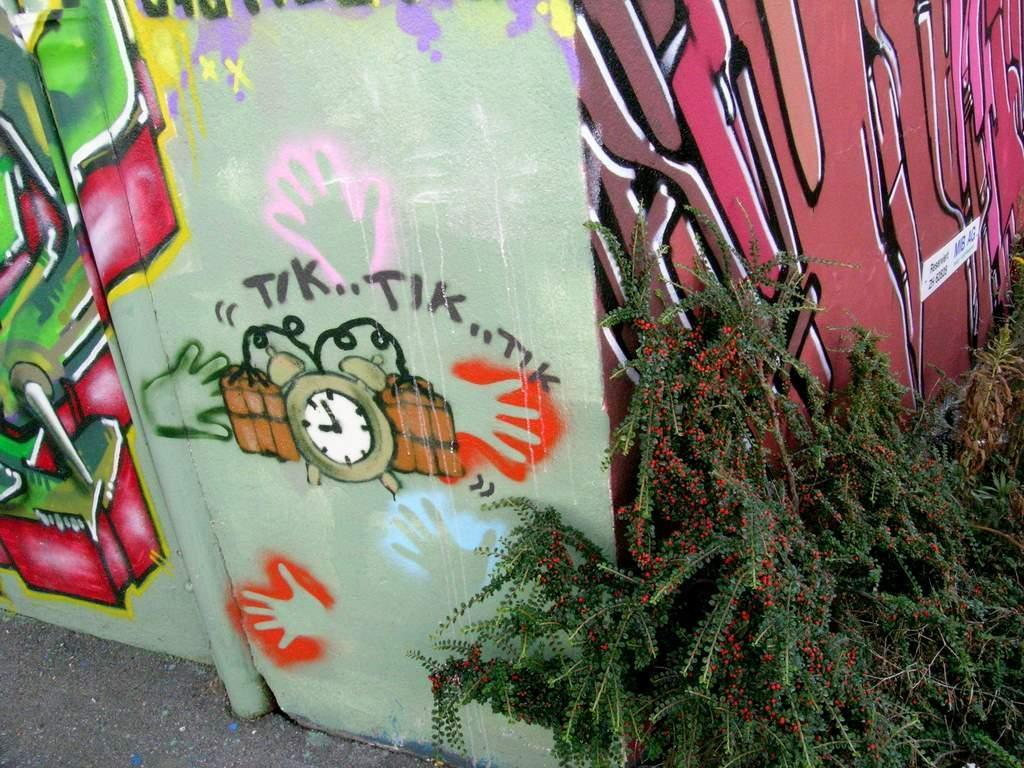In one or two sentences, can you explain what this image depicts? On the right side there are plants. Near to that there is a wall with graffiti. 